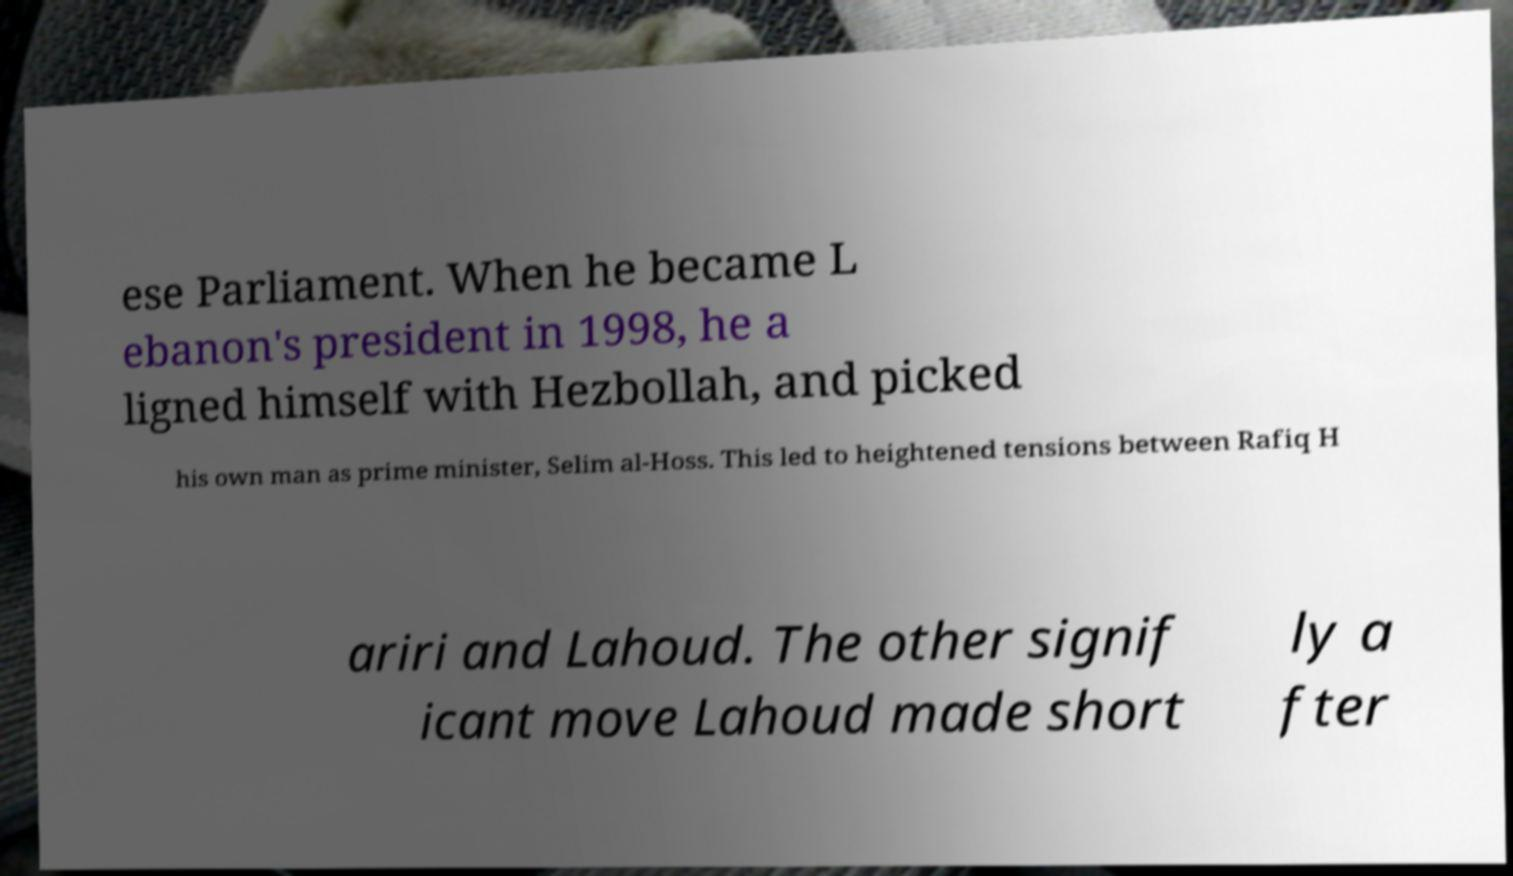Please identify and transcribe the text found in this image. ese Parliament. When he became L ebanon's president in 1998, he a ligned himself with Hezbollah, and picked his own man as prime minister, Selim al-Hoss. This led to heightened tensions between Rafiq H ariri and Lahoud. The other signif icant move Lahoud made short ly a fter 